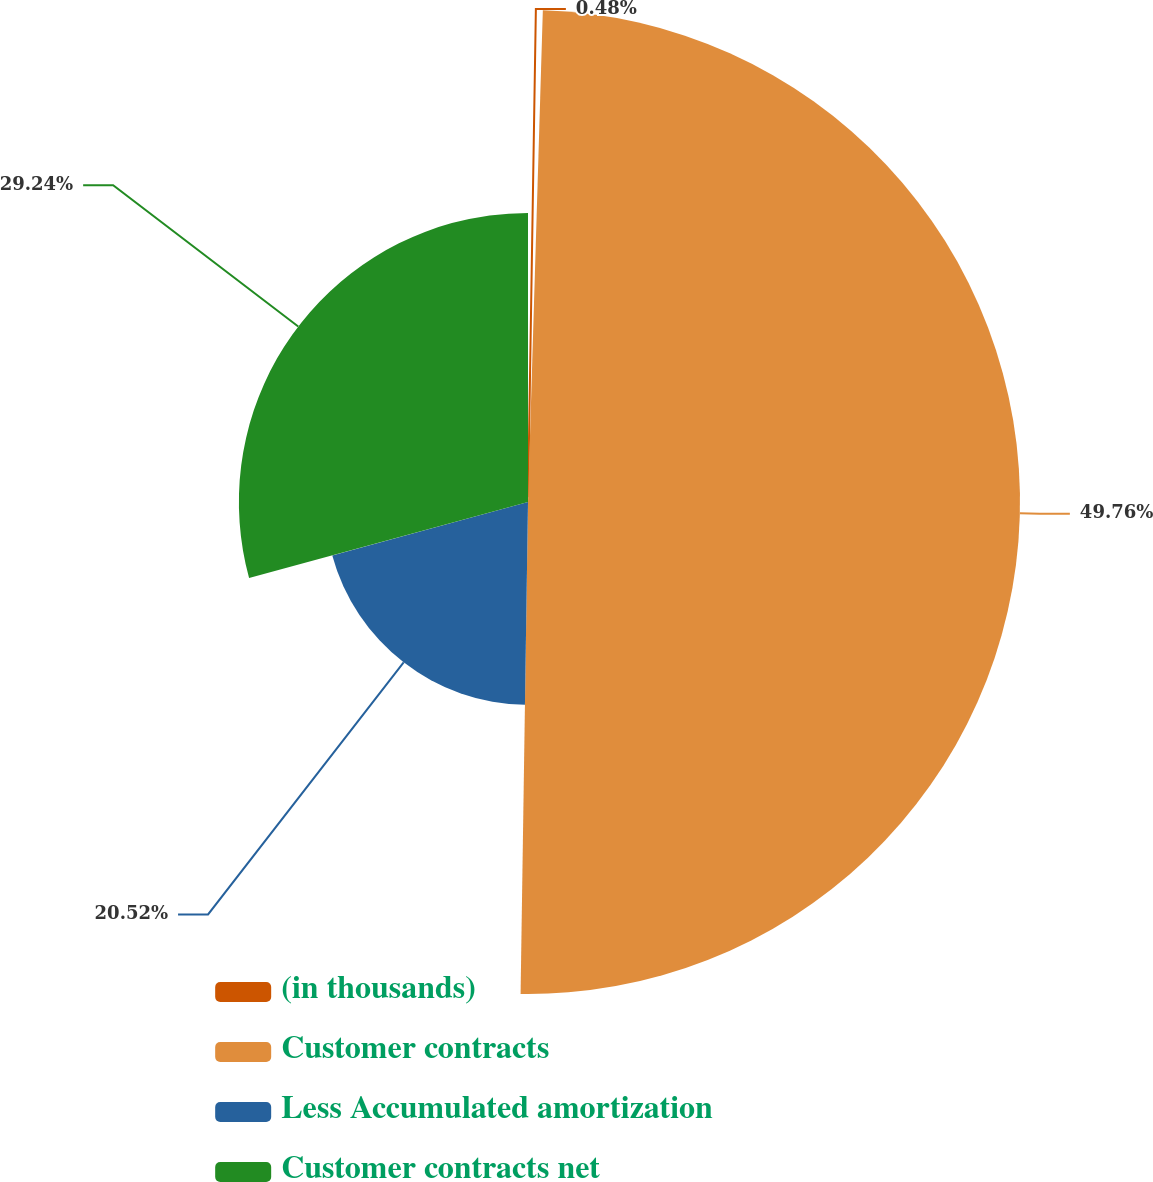Convert chart to OTSL. <chart><loc_0><loc_0><loc_500><loc_500><pie_chart><fcel>(in thousands)<fcel>Customer contracts<fcel>Less Accumulated amortization<fcel>Customer contracts net<nl><fcel>0.48%<fcel>49.76%<fcel>20.52%<fcel>29.24%<nl></chart> 